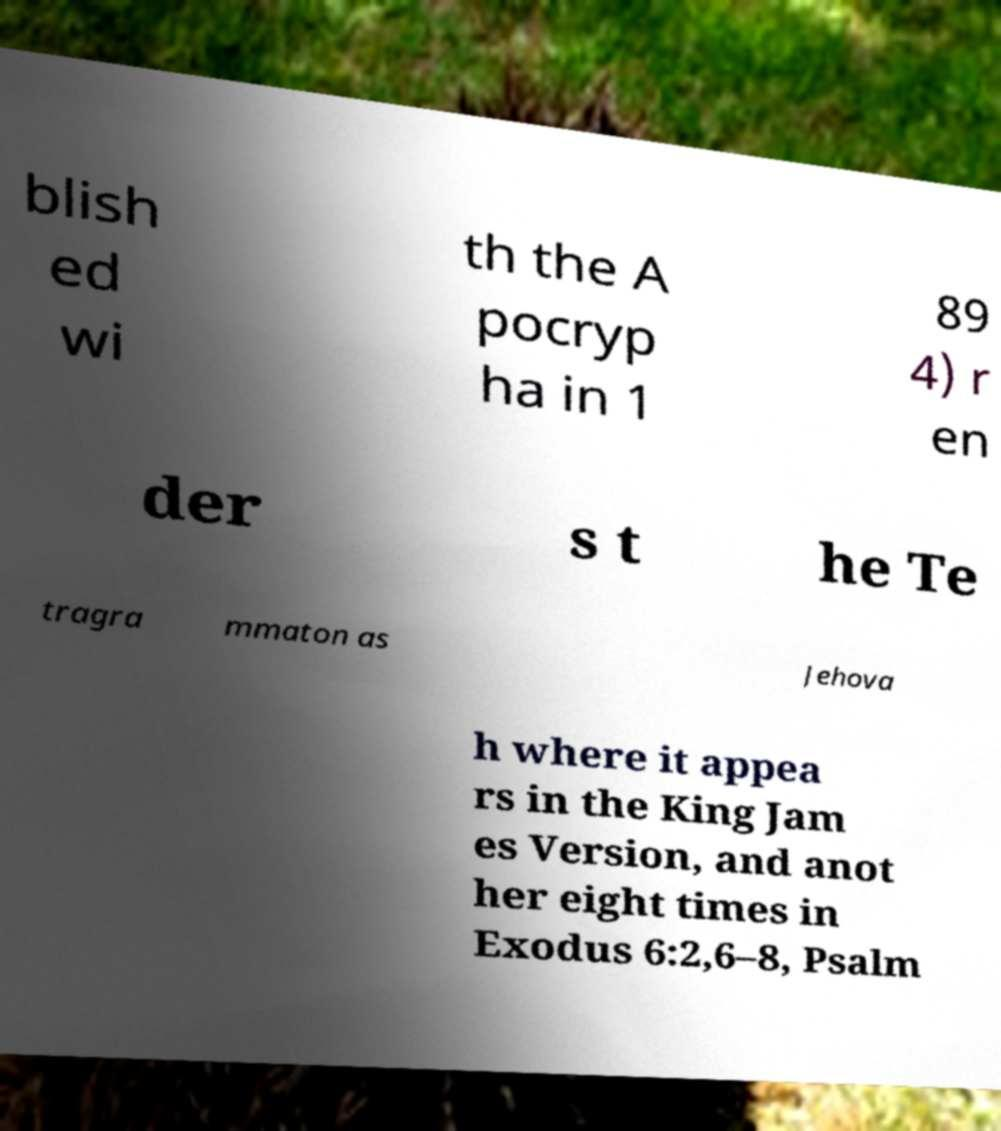I need the written content from this picture converted into text. Can you do that? blish ed wi th the A pocryp ha in 1 89 4) r en der s t he Te tragra mmaton as Jehova h where it appea rs in the King Jam es Version, and anot her eight times in Exodus 6:2,6–8, Psalm 